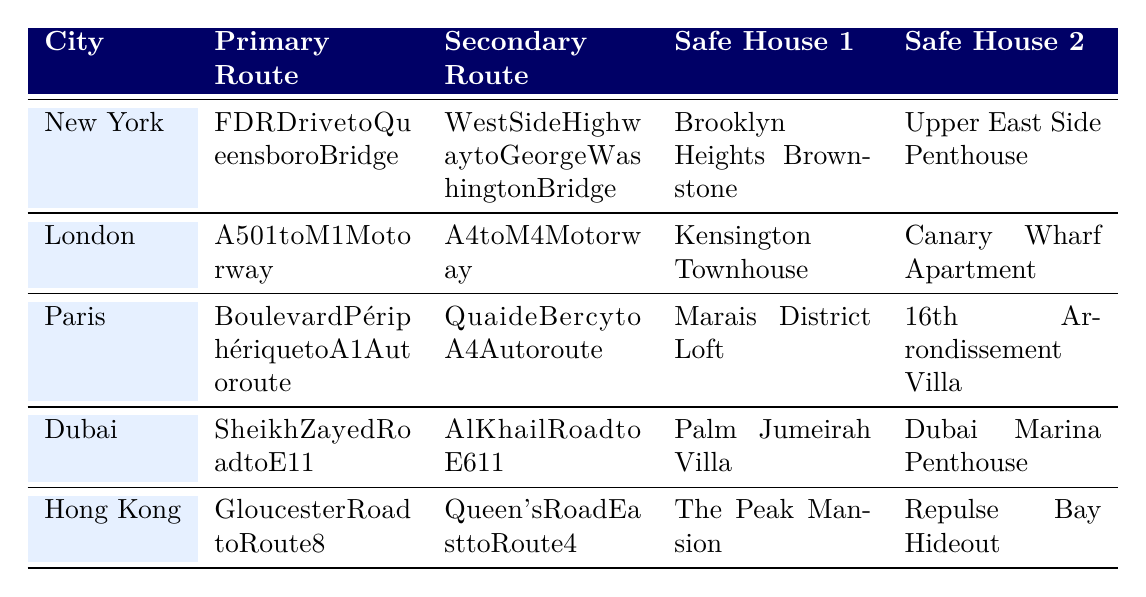What is the primary evacuation route for New York? The table shows that the primary evacuation route for New York is "FDR Drive to Queensboro Bridge."
Answer: FDR Drive to Queensboro Bridge Which city has the safe house located in "The Peak Mansion"? By looking at the safe house entries in the table, "The Peak Mansion" is listed under Hong Kong.
Answer: Hong Kong What are the secondary evacuation routes for both London and Dubai? In the table, London's secondary route is "A4 to M4 Motorway," and Dubai's secondary route is "Al Khail Road to E611."
Answer: A4 to M4 Motorway and Al Khail Road to E611 Is there a safe house listed in the table for Paris? Yes, the table includes two safe houses for Paris: "Marais District Loft" and "16th Arrondissement Villa."
Answer: Yes Which city has the longest evacuation route listed in the primary column? The primary routes are "FDR Drive to Queensboro Bridge," "A501 to M1 Motorway," "Boulevard Périphérique to A1 Autoroute," "Sheikh Zayed Road to E11," and "Gloucester Road to Route 8." Upon evaluating these routes, "Boulevard Périphérique to A1 Autoroute" from Paris seems to be the longest based on typical length.
Answer: Paris How many safe houses are available in total across all cities listed? The table shows two safe houses for each of the five cities, resulting in a total of 5 cities × 2 safe houses = 10 safe houses.
Answer: 10 If you were in Dubai, what would be the first safe house option? The first safe house listed for Dubai in the table is "Palm Jumeirah Villa."
Answer: Palm Jumeirah Villa Which city has the shortest name and what is its primary evacuation route? The table indicates that "Dubai" has the shortest name among the cities listed, and its primary route is "Sheikh Zayed Road to E11."
Answer: Dubai, Sheikh Zayed Road to E11 What is the difference between the primary routes of New York and Paris in terms of length? The primary routes are "FDR Drive to Queensboro Bridge" for New York and "Boulevard Périphérique to A1 Autoroute" for Paris. While the table does not provide lengths, it can typically be inferred that Boulevard Périphérique is longer based on familiar knowledge of city layouts. Hence, the primary route of New York is shorter than Paris.
Answer: New York's route is shorter What city has safe houses located in an apartment and a villa? The table shows two cities with a villa and an apartment: Dubai has "Palm Jumeirah Villa" and "Dubai Marina Penthouse."
Answer: Dubai 